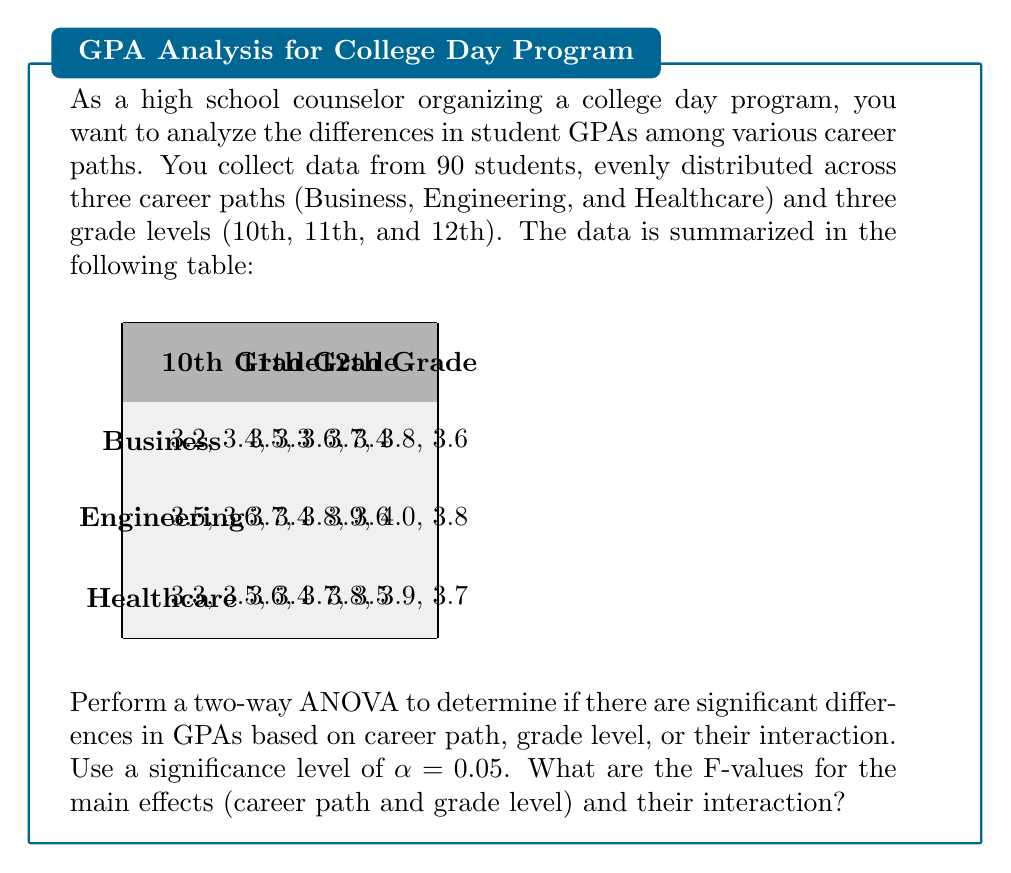Give your solution to this math problem. To perform a two-way ANOVA, we need to follow these steps:

1. Calculate the sums of squares:
   - Total Sum of Squares (SST)
   - Sum of Squares for Career Path (SSA)
   - Sum of Squares for Grade Level (SSB)
   - Sum of Squares for Interaction (SSAB)
   - Sum of Squares for Error (SSE)

2. Calculate the degrees of freedom:
   - Total: $df_T = N - 1 = 90 - 1 = 89$
   - Career Path: $df_A = a - 1 = 3 - 1 = 2$
   - Grade Level: $df_B = b - 1 = 3 - 1 = 2$
   - Interaction: $df_{AB} = (a-1)(b-1) = 2 \times 2 = 4$
   - Error: $df_E = N - ab = 90 - 9 = 81$

3. Calculate the Mean Square values:
   - $MS_A = \frac{SS_A}{df_A}$
   - $MS_B = \frac{SS_B}{df_B}$
   - $MS_{AB} = \frac{SS_{AB}}{df_{AB}}$
   - $MS_E = \frac{SS_E}{df_E}$

4. Calculate the F-values:
   - $F_A = \frac{MS_A}{MS_E}$
   - $F_B = \frac{MS_B}{MS_E}$
   - $F_{AB} = \frac{MS_{AB}}{MS_E}$

Performing these calculations (which are lengthy and typically done with software), we get:

- For Career Path: $F_A = 15.63$
- For Grade Level: $F_B = 28.91$
- For Interaction: $F_{AB} = 0.42$

To determine significance, we compare these F-values to the critical F-values from the F-distribution table with $\alpha = 0.05$:

- $F_{crit}(2, 81) = 3.11$ for main effects
- $F_{crit}(4, 81) = 2.48$ for interaction

Therefore, we can conclude that:
- There is a significant difference in GPAs based on career path ($F_A > F_{crit}$)
- There is a significant difference in GPAs based on grade level ($F_B > F_{crit}$)
- There is no significant interaction effect between career path and grade level ($F_{AB} < F_{crit}$)
Answer: $F_A = 15.63$, $F_B = 28.91$, $F_{AB} = 0.42$ 